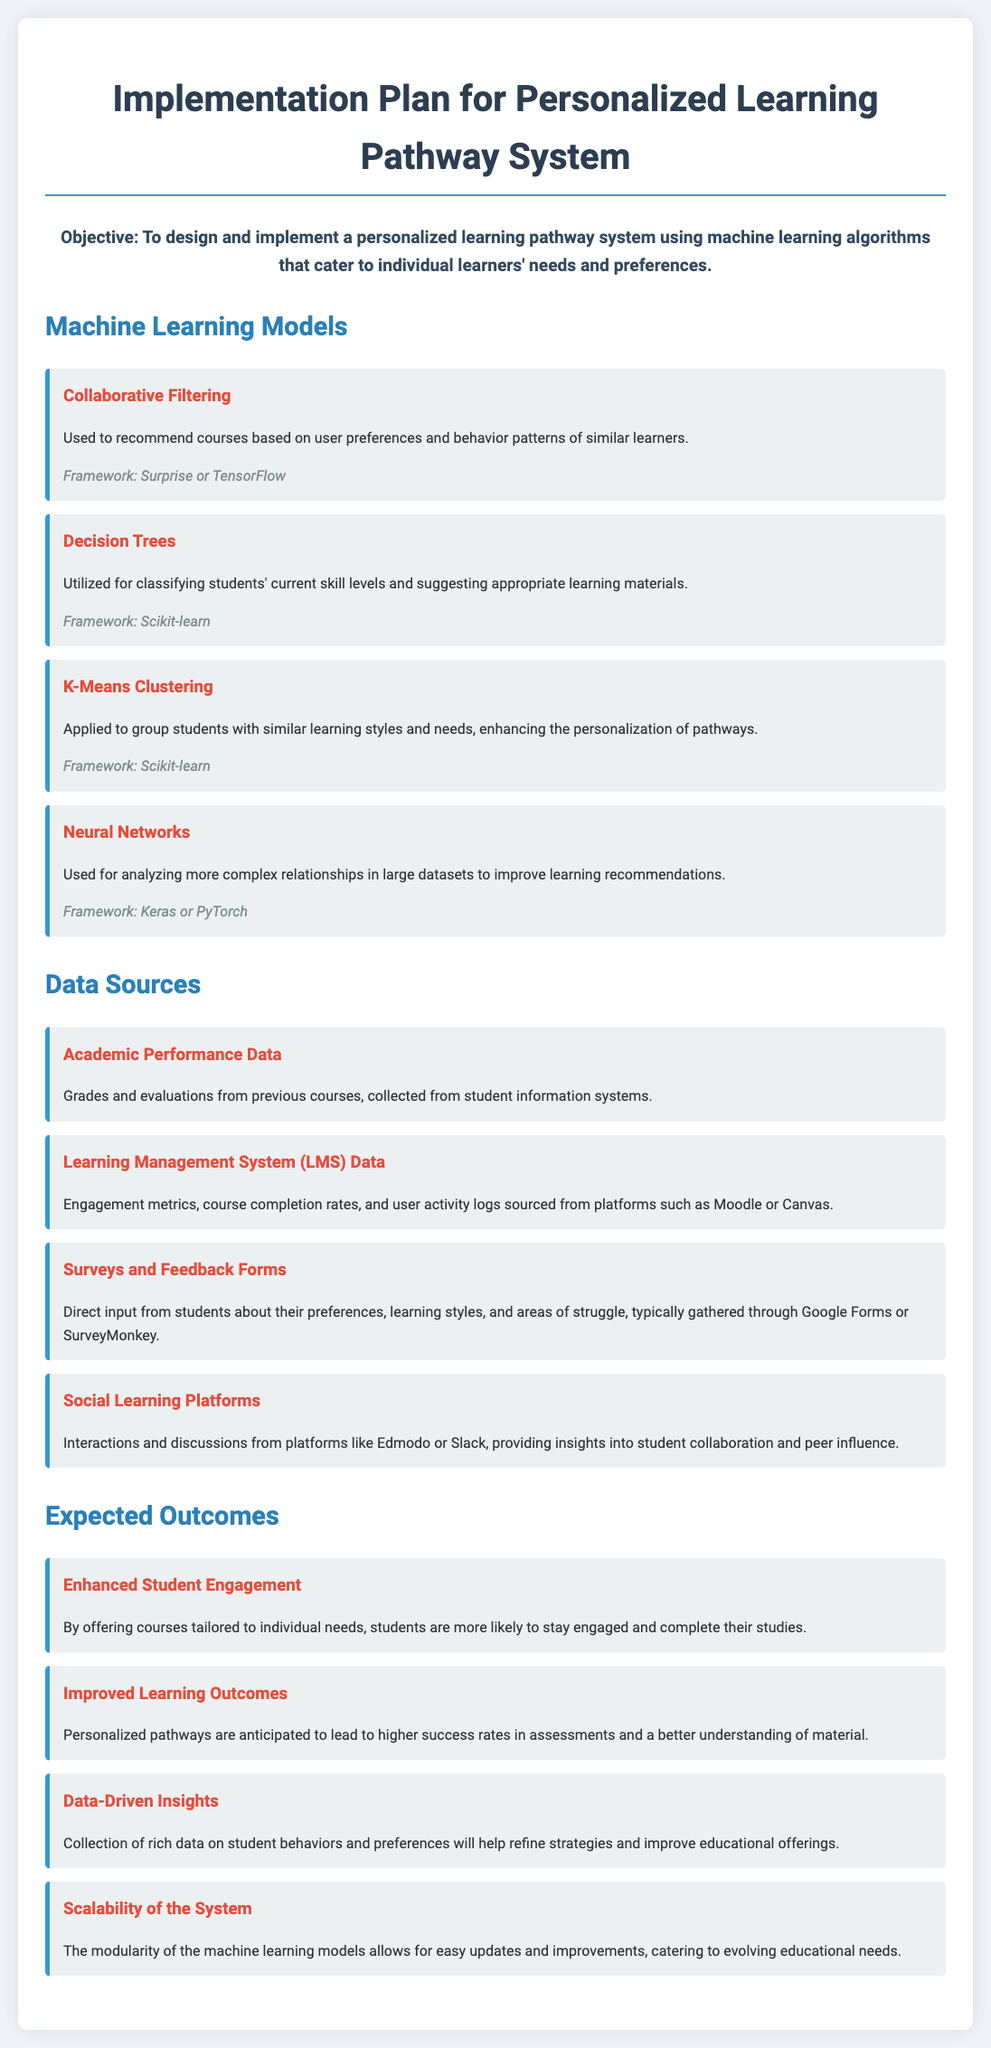What is the objective of the implementation plan? The objective is stated at the beginning of the document, focusing on designing and implementing a personalized learning pathway system using machine learning algorithms.
Answer: To design and implement a personalized learning pathway system using machine learning algorithms that cater to individual learners' needs and preferences What machine learning model is used for recommending courses? The document specifies that Collaborative Filtering is used to recommend courses based on user preferences and behavior patterns of similar learners.
Answer: Collaborative Filtering Which framework is used for Decision Trees? The framework mentioned in the document for Decision Trees is Scikit-learn.
Answer: Scikit-learn How many data sources are listed in the document? The document lists four different data sources used for the personalized learning pathway system.
Answer: Four What is one expected outcome related to student engagement? The document states that students are expected to be more engaged with courses tailored to their needs, indicating that enhanced student engagement is an anticipated outcome.
Answer: Enhanced Student Engagement What type of data is collected from Learning Management Systems? The document specifies that engagement metrics, course completion rates, and user activity logs are collected from Learning Management System data sources.
Answer: Engagement metrics, course completion rates, and user activity logs What is the role of K-Means Clustering in the system? K-Means Clustering is applied to group students with similar learning styles and needs, which enhances the personalization of pathways.
Answer: Group students with similar learning styles and needs Which machine learning framework is used for Neural Networks? The document mentions that Keras or PyTorch frameworks can be used for Neural Networks in the implementation of the system.
Answer: Keras or PyTorch 